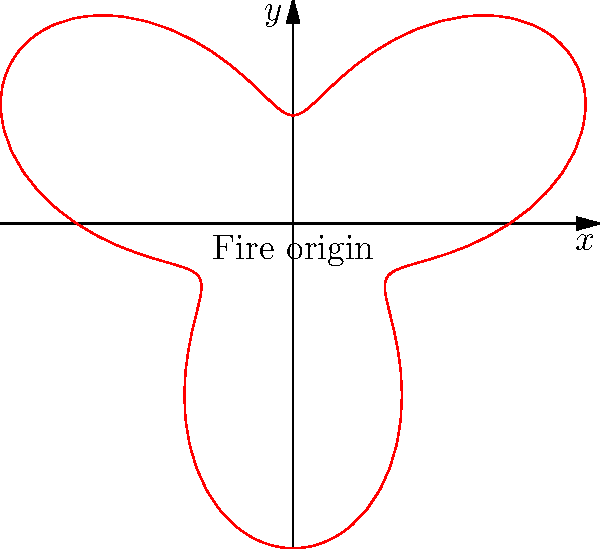A fire has broken out in your neighborhood, and its spread is being modeled using polar coordinates. The boundary of the affected area is given by the equation $r = 2 + \sin(3\theta)$, where $r$ is in kilometers. What is the maximum distance the fire has spread from its origin? To find the maximum distance the fire has spread, we need to determine the maximum value of $r$ in the given equation.

1. The equation of the fire's boundary is $r = 2 + \sin(3\theta)$.

2. The sine function always has a range between -1 and 1.

3. The maximum value of $\sin(3\theta)$ is 1.

4. Therefore, the maximum value of $r$ occurs when $\sin(3\theta) = 1$.

5. Substituting this into the equation:
   $r_{max} = 2 + 1 = 3$

6. This means the maximum distance the fire has spread is 3 kilometers from its origin.
Answer: 3 kilometers 